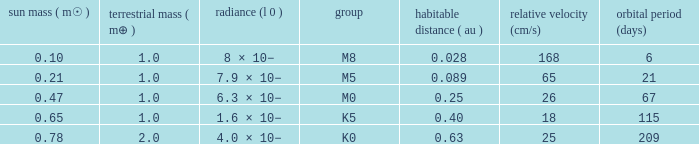What is the smallest period (days) to have a planetary mass of 1, a stellar mass greater than 0.21 and of the type M0? 67.0. 